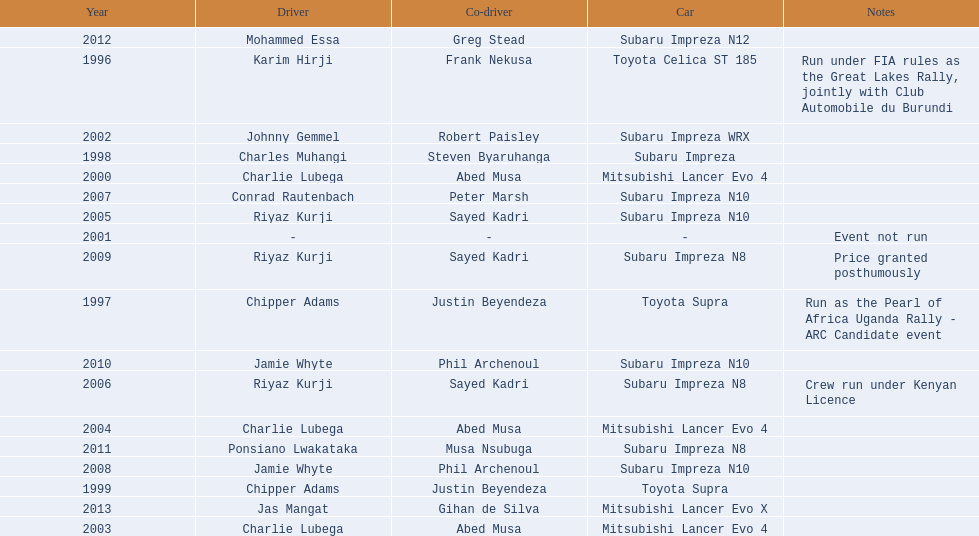What is the total number of times that the winning driver was driving a toyota supra? 2. 